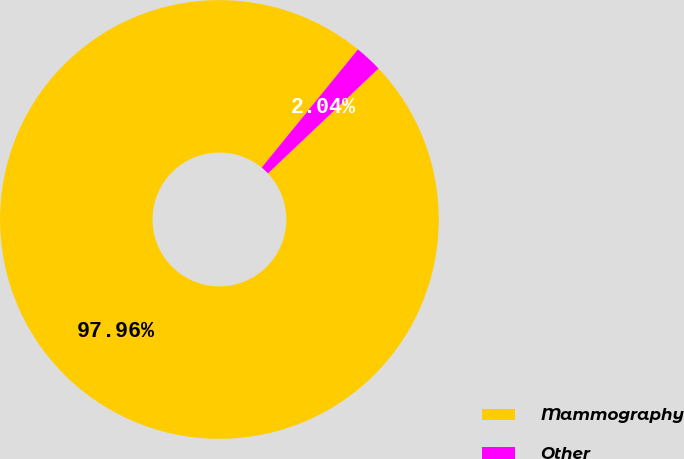Convert chart to OTSL. <chart><loc_0><loc_0><loc_500><loc_500><pie_chart><fcel>Mammography<fcel>Other<nl><fcel>97.96%<fcel>2.04%<nl></chart> 